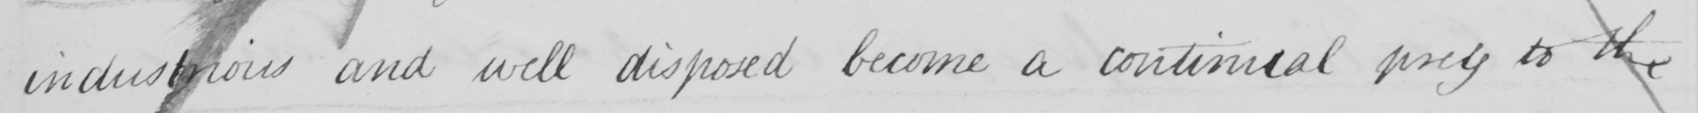Can you read and transcribe this handwriting? industrious and well disposed become a continual prey to the 